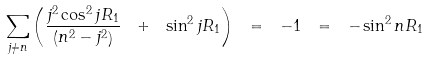Convert formula to latex. <formula><loc_0><loc_0><loc_500><loc_500>\sum _ { j \ne n } \left ( \frac { j ^ { 2 } \cos ^ { 2 } j R _ { 1 } } { \left ( n ^ { 2 } - j ^ { 2 } \right ) } \ + \ \sin ^ { 2 } j R _ { 1 } \right ) \ = \ - 1 \ = \ - \sin ^ { 2 } n R _ { 1 }</formula> 